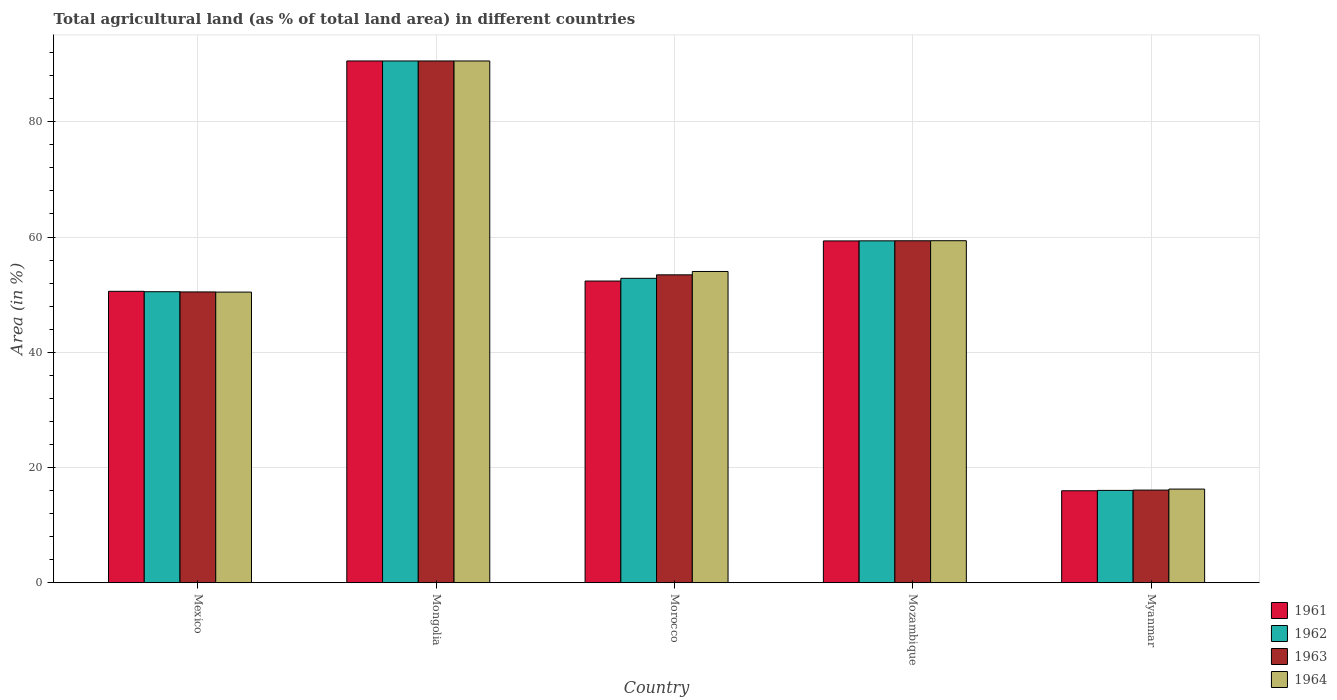How many groups of bars are there?
Give a very brief answer. 5. How many bars are there on the 5th tick from the right?
Your response must be concise. 4. What is the percentage of agricultural land in 1961 in Myanmar?
Ensure brevity in your answer.  15.96. Across all countries, what is the maximum percentage of agricultural land in 1962?
Make the answer very short. 90.56. Across all countries, what is the minimum percentage of agricultural land in 1964?
Ensure brevity in your answer.  16.25. In which country was the percentage of agricultural land in 1962 maximum?
Provide a short and direct response. Mongolia. In which country was the percentage of agricultural land in 1962 minimum?
Keep it short and to the point. Myanmar. What is the total percentage of agricultural land in 1961 in the graph?
Make the answer very short. 268.77. What is the difference between the percentage of agricultural land in 1963 in Morocco and that in Mozambique?
Offer a very short reply. -5.91. What is the difference between the percentage of agricultural land in 1961 in Mozambique and the percentage of agricultural land in 1963 in Myanmar?
Keep it short and to the point. 43.24. What is the average percentage of agricultural land in 1963 per country?
Your answer should be compact. 53.98. What is the difference between the percentage of agricultural land of/in 1963 and percentage of agricultural land of/in 1962 in Myanmar?
Provide a short and direct response. 0.06. What is the ratio of the percentage of agricultural land in 1964 in Morocco to that in Mozambique?
Your answer should be very brief. 0.91. What is the difference between the highest and the second highest percentage of agricultural land in 1961?
Offer a terse response. 31.23. What is the difference between the highest and the lowest percentage of agricultural land in 1961?
Ensure brevity in your answer.  74.6. In how many countries, is the percentage of agricultural land in 1962 greater than the average percentage of agricultural land in 1962 taken over all countries?
Make the answer very short. 2. What does the 3rd bar from the left in Mongolia represents?
Keep it short and to the point. 1963. What does the 4th bar from the right in Mexico represents?
Keep it short and to the point. 1961. How many bars are there?
Offer a very short reply. 20. How many countries are there in the graph?
Offer a very short reply. 5. What is the difference between two consecutive major ticks on the Y-axis?
Keep it short and to the point. 20. Are the values on the major ticks of Y-axis written in scientific E-notation?
Provide a short and direct response. No. Does the graph contain any zero values?
Provide a succinct answer. No. Where does the legend appear in the graph?
Keep it short and to the point. Bottom right. How many legend labels are there?
Provide a succinct answer. 4. How are the legend labels stacked?
Offer a terse response. Vertical. What is the title of the graph?
Provide a succinct answer. Total agricultural land (as % of total land area) in different countries. Does "1983" appear as one of the legend labels in the graph?
Your answer should be compact. No. What is the label or title of the X-axis?
Provide a short and direct response. Country. What is the label or title of the Y-axis?
Provide a short and direct response. Area (in %). What is the Area (in %) of 1961 in Mexico?
Provide a succinct answer. 50.58. What is the Area (in %) in 1962 in Mexico?
Make the answer very short. 50.5. What is the Area (in %) of 1963 in Mexico?
Make the answer very short. 50.47. What is the Area (in %) of 1964 in Mexico?
Offer a terse response. 50.44. What is the Area (in %) of 1961 in Mongolia?
Keep it short and to the point. 90.56. What is the Area (in %) in 1962 in Mongolia?
Offer a very short reply. 90.56. What is the Area (in %) in 1963 in Mongolia?
Offer a very short reply. 90.56. What is the Area (in %) in 1964 in Mongolia?
Give a very brief answer. 90.55. What is the Area (in %) in 1961 in Morocco?
Offer a very short reply. 52.36. What is the Area (in %) of 1962 in Morocco?
Offer a very short reply. 52.83. What is the Area (in %) of 1963 in Morocco?
Keep it short and to the point. 53.43. What is the Area (in %) of 1964 in Morocco?
Offer a terse response. 54.02. What is the Area (in %) in 1961 in Mozambique?
Offer a very short reply. 59.32. What is the Area (in %) of 1962 in Mozambique?
Keep it short and to the point. 59.34. What is the Area (in %) in 1963 in Mozambique?
Make the answer very short. 59.35. What is the Area (in %) of 1964 in Mozambique?
Provide a succinct answer. 59.36. What is the Area (in %) in 1961 in Myanmar?
Offer a very short reply. 15.96. What is the Area (in %) in 1962 in Myanmar?
Your answer should be compact. 16.02. What is the Area (in %) in 1963 in Myanmar?
Give a very brief answer. 16.08. What is the Area (in %) of 1964 in Myanmar?
Offer a terse response. 16.25. Across all countries, what is the maximum Area (in %) in 1961?
Your response must be concise. 90.56. Across all countries, what is the maximum Area (in %) in 1962?
Provide a succinct answer. 90.56. Across all countries, what is the maximum Area (in %) of 1963?
Offer a terse response. 90.56. Across all countries, what is the maximum Area (in %) of 1964?
Keep it short and to the point. 90.55. Across all countries, what is the minimum Area (in %) of 1961?
Give a very brief answer. 15.96. Across all countries, what is the minimum Area (in %) of 1962?
Keep it short and to the point. 16.02. Across all countries, what is the minimum Area (in %) in 1963?
Your response must be concise. 16.08. Across all countries, what is the minimum Area (in %) in 1964?
Your answer should be very brief. 16.25. What is the total Area (in %) of 1961 in the graph?
Make the answer very short. 268.77. What is the total Area (in %) in 1962 in the graph?
Your answer should be compact. 269.25. What is the total Area (in %) of 1963 in the graph?
Keep it short and to the point. 269.88. What is the total Area (in %) of 1964 in the graph?
Give a very brief answer. 270.62. What is the difference between the Area (in %) in 1961 in Mexico and that in Mongolia?
Your response must be concise. -39.98. What is the difference between the Area (in %) of 1962 in Mexico and that in Mongolia?
Make the answer very short. -40.05. What is the difference between the Area (in %) in 1963 in Mexico and that in Mongolia?
Make the answer very short. -40.09. What is the difference between the Area (in %) in 1964 in Mexico and that in Mongolia?
Ensure brevity in your answer.  -40.12. What is the difference between the Area (in %) in 1961 in Mexico and that in Morocco?
Offer a very short reply. -1.78. What is the difference between the Area (in %) in 1962 in Mexico and that in Morocco?
Your answer should be compact. -2.32. What is the difference between the Area (in %) of 1963 in Mexico and that in Morocco?
Keep it short and to the point. -2.97. What is the difference between the Area (in %) of 1964 in Mexico and that in Morocco?
Offer a terse response. -3.58. What is the difference between the Area (in %) in 1961 in Mexico and that in Mozambique?
Offer a very short reply. -8.75. What is the difference between the Area (in %) of 1962 in Mexico and that in Mozambique?
Provide a short and direct response. -8.83. What is the difference between the Area (in %) of 1963 in Mexico and that in Mozambique?
Make the answer very short. -8.88. What is the difference between the Area (in %) of 1964 in Mexico and that in Mozambique?
Ensure brevity in your answer.  -8.92. What is the difference between the Area (in %) of 1961 in Mexico and that in Myanmar?
Make the answer very short. 34.62. What is the difference between the Area (in %) of 1962 in Mexico and that in Myanmar?
Offer a very short reply. 34.48. What is the difference between the Area (in %) of 1963 in Mexico and that in Myanmar?
Ensure brevity in your answer.  34.39. What is the difference between the Area (in %) in 1964 in Mexico and that in Myanmar?
Make the answer very short. 34.19. What is the difference between the Area (in %) of 1961 in Mongolia and that in Morocco?
Offer a terse response. 38.2. What is the difference between the Area (in %) of 1962 in Mongolia and that in Morocco?
Keep it short and to the point. 37.73. What is the difference between the Area (in %) in 1963 in Mongolia and that in Morocco?
Offer a terse response. 37.12. What is the difference between the Area (in %) in 1964 in Mongolia and that in Morocco?
Provide a succinct answer. 36.54. What is the difference between the Area (in %) in 1961 in Mongolia and that in Mozambique?
Provide a short and direct response. 31.23. What is the difference between the Area (in %) of 1962 in Mongolia and that in Mozambique?
Provide a short and direct response. 31.22. What is the difference between the Area (in %) of 1963 in Mongolia and that in Mozambique?
Offer a very short reply. 31.21. What is the difference between the Area (in %) in 1964 in Mongolia and that in Mozambique?
Your response must be concise. 31.2. What is the difference between the Area (in %) of 1961 in Mongolia and that in Myanmar?
Offer a very short reply. 74.6. What is the difference between the Area (in %) in 1962 in Mongolia and that in Myanmar?
Provide a short and direct response. 74.53. What is the difference between the Area (in %) of 1963 in Mongolia and that in Myanmar?
Provide a succinct answer. 74.48. What is the difference between the Area (in %) of 1964 in Mongolia and that in Myanmar?
Offer a terse response. 74.3. What is the difference between the Area (in %) in 1961 in Morocco and that in Mozambique?
Ensure brevity in your answer.  -6.96. What is the difference between the Area (in %) of 1962 in Morocco and that in Mozambique?
Offer a terse response. -6.51. What is the difference between the Area (in %) of 1963 in Morocco and that in Mozambique?
Your response must be concise. -5.91. What is the difference between the Area (in %) in 1964 in Morocco and that in Mozambique?
Keep it short and to the point. -5.34. What is the difference between the Area (in %) in 1961 in Morocco and that in Myanmar?
Offer a very short reply. 36.4. What is the difference between the Area (in %) in 1962 in Morocco and that in Myanmar?
Offer a terse response. 36.81. What is the difference between the Area (in %) in 1963 in Morocco and that in Myanmar?
Offer a very short reply. 37.36. What is the difference between the Area (in %) in 1964 in Morocco and that in Myanmar?
Your response must be concise. 37.77. What is the difference between the Area (in %) of 1961 in Mozambique and that in Myanmar?
Offer a very short reply. 43.36. What is the difference between the Area (in %) of 1962 in Mozambique and that in Myanmar?
Your response must be concise. 43.31. What is the difference between the Area (in %) of 1963 in Mozambique and that in Myanmar?
Your answer should be very brief. 43.27. What is the difference between the Area (in %) in 1964 in Mozambique and that in Myanmar?
Your answer should be very brief. 43.11. What is the difference between the Area (in %) of 1961 in Mexico and the Area (in %) of 1962 in Mongolia?
Your response must be concise. -39.98. What is the difference between the Area (in %) in 1961 in Mexico and the Area (in %) in 1963 in Mongolia?
Provide a succinct answer. -39.98. What is the difference between the Area (in %) in 1961 in Mexico and the Area (in %) in 1964 in Mongolia?
Your answer should be very brief. -39.98. What is the difference between the Area (in %) of 1962 in Mexico and the Area (in %) of 1963 in Mongolia?
Ensure brevity in your answer.  -40.05. What is the difference between the Area (in %) in 1962 in Mexico and the Area (in %) in 1964 in Mongolia?
Keep it short and to the point. -40.05. What is the difference between the Area (in %) in 1963 in Mexico and the Area (in %) in 1964 in Mongolia?
Offer a terse response. -40.09. What is the difference between the Area (in %) in 1961 in Mexico and the Area (in %) in 1962 in Morocco?
Offer a terse response. -2.25. What is the difference between the Area (in %) of 1961 in Mexico and the Area (in %) of 1963 in Morocco?
Offer a very short reply. -2.86. What is the difference between the Area (in %) of 1961 in Mexico and the Area (in %) of 1964 in Morocco?
Ensure brevity in your answer.  -3.44. What is the difference between the Area (in %) of 1962 in Mexico and the Area (in %) of 1963 in Morocco?
Keep it short and to the point. -2.93. What is the difference between the Area (in %) of 1962 in Mexico and the Area (in %) of 1964 in Morocco?
Provide a succinct answer. -3.51. What is the difference between the Area (in %) in 1963 in Mexico and the Area (in %) in 1964 in Morocco?
Your answer should be compact. -3.55. What is the difference between the Area (in %) of 1961 in Mexico and the Area (in %) of 1962 in Mozambique?
Ensure brevity in your answer.  -8.76. What is the difference between the Area (in %) of 1961 in Mexico and the Area (in %) of 1963 in Mozambique?
Your response must be concise. -8.77. What is the difference between the Area (in %) in 1961 in Mexico and the Area (in %) in 1964 in Mozambique?
Offer a terse response. -8.78. What is the difference between the Area (in %) of 1962 in Mexico and the Area (in %) of 1963 in Mozambique?
Make the answer very short. -8.84. What is the difference between the Area (in %) in 1962 in Mexico and the Area (in %) in 1964 in Mozambique?
Offer a terse response. -8.85. What is the difference between the Area (in %) of 1963 in Mexico and the Area (in %) of 1964 in Mozambique?
Your answer should be very brief. -8.89. What is the difference between the Area (in %) in 1961 in Mexico and the Area (in %) in 1962 in Myanmar?
Your answer should be very brief. 34.55. What is the difference between the Area (in %) of 1961 in Mexico and the Area (in %) of 1963 in Myanmar?
Make the answer very short. 34.5. What is the difference between the Area (in %) in 1961 in Mexico and the Area (in %) in 1964 in Myanmar?
Your response must be concise. 34.33. What is the difference between the Area (in %) in 1962 in Mexico and the Area (in %) in 1963 in Myanmar?
Give a very brief answer. 34.43. What is the difference between the Area (in %) in 1962 in Mexico and the Area (in %) in 1964 in Myanmar?
Make the answer very short. 34.25. What is the difference between the Area (in %) in 1963 in Mexico and the Area (in %) in 1964 in Myanmar?
Offer a very short reply. 34.22. What is the difference between the Area (in %) of 1961 in Mongolia and the Area (in %) of 1962 in Morocco?
Your answer should be very brief. 37.73. What is the difference between the Area (in %) in 1961 in Mongolia and the Area (in %) in 1963 in Morocco?
Keep it short and to the point. 37.12. What is the difference between the Area (in %) in 1961 in Mongolia and the Area (in %) in 1964 in Morocco?
Offer a very short reply. 36.54. What is the difference between the Area (in %) in 1962 in Mongolia and the Area (in %) in 1963 in Morocco?
Offer a terse response. 37.12. What is the difference between the Area (in %) of 1962 in Mongolia and the Area (in %) of 1964 in Morocco?
Provide a short and direct response. 36.54. What is the difference between the Area (in %) in 1963 in Mongolia and the Area (in %) in 1964 in Morocco?
Your answer should be compact. 36.54. What is the difference between the Area (in %) of 1961 in Mongolia and the Area (in %) of 1962 in Mozambique?
Give a very brief answer. 31.22. What is the difference between the Area (in %) in 1961 in Mongolia and the Area (in %) in 1963 in Mozambique?
Offer a very short reply. 31.21. What is the difference between the Area (in %) in 1961 in Mongolia and the Area (in %) in 1964 in Mozambique?
Offer a terse response. 31.2. What is the difference between the Area (in %) of 1962 in Mongolia and the Area (in %) of 1963 in Mozambique?
Give a very brief answer. 31.21. What is the difference between the Area (in %) of 1962 in Mongolia and the Area (in %) of 1964 in Mozambique?
Make the answer very short. 31.2. What is the difference between the Area (in %) in 1963 in Mongolia and the Area (in %) in 1964 in Mozambique?
Your answer should be very brief. 31.2. What is the difference between the Area (in %) in 1961 in Mongolia and the Area (in %) in 1962 in Myanmar?
Your answer should be very brief. 74.53. What is the difference between the Area (in %) of 1961 in Mongolia and the Area (in %) of 1963 in Myanmar?
Offer a terse response. 74.48. What is the difference between the Area (in %) in 1961 in Mongolia and the Area (in %) in 1964 in Myanmar?
Keep it short and to the point. 74.31. What is the difference between the Area (in %) in 1962 in Mongolia and the Area (in %) in 1963 in Myanmar?
Offer a very short reply. 74.48. What is the difference between the Area (in %) in 1962 in Mongolia and the Area (in %) in 1964 in Myanmar?
Make the answer very short. 74.31. What is the difference between the Area (in %) of 1963 in Mongolia and the Area (in %) of 1964 in Myanmar?
Offer a terse response. 74.31. What is the difference between the Area (in %) in 1961 in Morocco and the Area (in %) in 1962 in Mozambique?
Your response must be concise. -6.98. What is the difference between the Area (in %) of 1961 in Morocco and the Area (in %) of 1963 in Mozambique?
Your answer should be compact. -6.99. What is the difference between the Area (in %) of 1961 in Morocco and the Area (in %) of 1964 in Mozambique?
Provide a succinct answer. -7. What is the difference between the Area (in %) in 1962 in Morocco and the Area (in %) in 1963 in Mozambique?
Make the answer very short. -6.52. What is the difference between the Area (in %) in 1962 in Morocco and the Area (in %) in 1964 in Mozambique?
Keep it short and to the point. -6.53. What is the difference between the Area (in %) of 1963 in Morocco and the Area (in %) of 1964 in Mozambique?
Provide a short and direct response. -5.92. What is the difference between the Area (in %) of 1961 in Morocco and the Area (in %) of 1962 in Myanmar?
Offer a very short reply. 36.34. What is the difference between the Area (in %) of 1961 in Morocco and the Area (in %) of 1963 in Myanmar?
Offer a terse response. 36.28. What is the difference between the Area (in %) of 1961 in Morocco and the Area (in %) of 1964 in Myanmar?
Provide a short and direct response. 36.11. What is the difference between the Area (in %) in 1962 in Morocco and the Area (in %) in 1963 in Myanmar?
Your answer should be very brief. 36.75. What is the difference between the Area (in %) of 1962 in Morocco and the Area (in %) of 1964 in Myanmar?
Give a very brief answer. 36.58. What is the difference between the Area (in %) in 1963 in Morocco and the Area (in %) in 1964 in Myanmar?
Give a very brief answer. 37.18. What is the difference between the Area (in %) in 1961 in Mozambique and the Area (in %) in 1962 in Myanmar?
Provide a short and direct response. 43.3. What is the difference between the Area (in %) in 1961 in Mozambique and the Area (in %) in 1963 in Myanmar?
Your response must be concise. 43.24. What is the difference between the Area (in %) in 1961 in Mozambique and the Area (in %) in 1964 in Myanmar?
Offer a very short reply. 43.07. What is the difference between the Area (in %) in 1962 in Mozambique and the Area (in %) in 1963 in Myanmar?
Keep it short and to the point. 43.26. What is the difference between the Area (in %) of 1962 in Mozambique and the Area (in %) of 1964 in Myanmar?
Give a very brief answer. 43.09. What is the difference between the Area (in %) in 1963 in Mozambique and the Area (in %) in 1964 in Myanmar?
Offer a terse response. 43.1. What is the average Area (in %) of 1961 per country?
Your response must be concise. 53.75. What is the average Area (in %) of 1962 per country?
Offer a terse response. 53.85. What is the average Area (in %) of 1963 per country?
Ensure brevity in your answer.  53.98. What is the average Area (in %) in 1964 per country?
Make the answer very short. 54.12. What is the difference between the Area (in %) in 1961 and Area (in %) in 1962 in Mexico?
Provide a short and direct response. 0.07. What is the difference between the Area (in %) in 1961 and Area (in %) in 1963 in Mexico?
Ensure brevity in your answer.  0.11. What is the difference between the Area (in %) of 1961 and Area (in %) of 1964 in Mexico?
Make the answer very short. 0.14. What is the difference between the Area (in %) of 1962 and Area (in %) of 1963 in Mexico?
Provide a succinct answer. 0.04. What is the difference between the Area (in %) of 1962 and Area (in %) of 1964 in Mexico?
Your answer should be compact. 0.07. What is the difference between the Area (in %) of 1963 and Area (in %) of 1964 in Mexico?
Ensure brevity in your answer.  0.03. What is the difference between the Area (in %) in 1961 and Area (in %) in 1964 in Mongolia?
Provide a short and direct response. 0. What is the difference between the Area (in %) of 1962 and Area (in %) of 1963 in Mongolia?
Ensure brevity in your answer.  0. What is the difference between the Area (in %) of 1962 and Area (in %) of 1964 in Mongolia?
Ensure brevity in your answer.  0. What is the difference between the Area (in %) of 1963 and Area (in %) of 1964 in Mongolia?
Make the answer very short. 0. What is the difference between the Area (in %) in 1961 and Area (in %) in 1962 in Morocco?
Keep it short and to the point. -0.47. What is the difference between the Area (in %) of 1961 and Area (in %) of 1963 in Morocco?
Ensure brevity in your answer.  -1.08. What is the difference between the Area (in %) of 1961 and Area (in %) of 1964 in Morocco?
Provide a succinct answer. -1.66. What is the difference between the Area (in %) of 1962 and Area (in %) of 1963 in Morocco?
Provide a short and direct response. -0.6. What is the difference between the Area (in %) of 1962 and Area (in %) of 1964 in Morocco?
Keep it short and to the point. -1.19. What is the difference between the Area (in %) of 1963 and Area (in %) of 1964 in Morocco?
Offer a very short reply. -0.58. What is the difference between the Area (in %) of 1961 and Area (in %) of 1962 in Mozambique?
Offer a terse response. -0.01. What is the difference between the Area (in %) of 1961 and Area (in %) of 1963 in Mozambique?
Give a very brief answer. -0.03. What is the difference between the Area (in %) of 1961 and Area (in %) of 1964 in Mozambique?
Your answer should be very brief. -0.04. What is the difference between the Area (in %) in 1962 and Area (in %) in 1963 in Mozambique?
Provide a succinct answer. -0.01. What is the difference between the Area (in %) of 1962 and Area (in %) of 1964 in Mozambique?
Your answer should be very brief. -0.02. What is the difference between the Area (in %) in 1963 and Area (in %) in 1964 in Mozambique?
Make the answer very short. -0.01. What is the difference between the Area (in %) of 1961 and Area (in %) of 1962 in Myanmar?
Keep it short and to the point. -0.06. What is the difference between the Area (in %) in 1961 and Area (in %) in 1963 in Myanmar?
Offer a terse response. -0.12. What is the difference between the Area (in %) in 1961 and Area (in %) in 1964 in Myanmar?
Your answer should be compact. -0.29. What is the difference between the Area (in %) in 1962 and Area (in %) in 1963 in Myanmar?
Provide a succinct answer. -0.06. What is the difference between the Area (in %) of 1962 and Area (in %) of 1964 in Myanmar?
Your answer should be very brief. -0.23. What is the difference between the Area (in %) in 1963 and Area (in %) in 1964 in Myanmar?
Keep it short and to the point. -0.17. What is the ratio of the Area (in %) in 1961 in Mexico to that in Mongolia?
Keep it short and to the point. 0.56. What is the ratio of the Area (in %) of 1962 in Mexico to that in Mongolia?
Make the answer very short. 0.56. What is the ratio of the Area (in %) of 1963 in Mexico to that in Mongolia?
Keep it short and to the point. 0.56. What is the ratio of the Area (in %) in 1964 in Mexico to that in Mongolia?
Keep it short and to the point. 0.56. What is the ratio of the Area (in %) of 1961 in Mexico to that in Morocco?
Ensure brevity in your answer.  0.97. What is the ratio of the Area (in %) in 1962 in Mexico to that in Morocco?
Your answer should be compact. 0.96. What is the ratio of the Area (in %) of 1963 in Mexico to that in Morocco?
Offer a terse response. 0.94. What is the ratio of the Area (in %) in 1964 in Mexico to that in Morocco?
Give a very brief answer. 0.93. What is the ratio of the Area (in %) of 1961 in Mexico to that in Mozambique?
Offer a very short reply. 0.85. What is the ratio of the Area (in %) of 1962 in Mexico to that in Mozambique?
Offer a very short reply. 0.85. What is the ratio of the Area (in %) of 1963 in Mexico to that in Mozambique?
Give a very brief answer. 0.85. What is the ratio of the Area (in %) in 1964 in Mexico to that in Mozambique?
Provide a short and direct response. 0.85. What is the ratio of the Area (in %) of 1961 in Mexico to that in Myanmar?
Provide a short and direct response. 3.17. What is the ratio of the Area (in %) in 1962 in Mexico to that in Myanmar?
Provide a succinct answer. 3.15. What is the ratio of the Area (in %) of 1963 in Mexico to that in Myanmar?
Your answer should be compact. 3.14. What is the ratio of the Area (in %) of 1964 in Mexico to that in Myanmar?
Offer a very short reply. 3.1. What is the ratio of the Area (in %) in 1961 in Mongolia to that in Morocco?
Give a very brief answer. 1.73. What is the ratio of the Area (in %) of 1962 in Mongolia to that in Morocco?
Provide a short and direct response. 1.71. What is the ratio of the Area (in %) of 1963 in Mongolia to that in Morocco?
Provide a short and direct response. 1.69. What is the ratio of the Area (in %) in 1964 in Mongolia to that in Morocco?
Offer a very short reply. 1.68. What is the ratio of the Area (in %) in 1961 in Mongolia to that in Mozambique?
Your response must be concise. 1.53. What is the ratio of the Area (in %) of 1962 in Mongolia to that in Mozambique?
Your answer should be very brief. 1.53. What is the ratio of the Area (in %) in 1963 in Mongolia to that in Mozambique?
Offer a very short reply. 1.53. What is the ratio of the Area (in %) in 1964 in Mongolia to that in Mozambique?
Offer a very short reply. 1.53. What is the ratio of the Area (in %) in 1961 in Mongolia to that in Myanmar?
Give a very brief answer. 5.67. What is the ratio of the Area (in %) in 1962 in Mongolia to that in Myanmar?
Your answer should be compact. 5.65. What is the ratio of the Area (in %) of 1963 in Mongolia to that in Myanmar?
Your answer should be compact. 5.63. What is the ratio of the Area (in %) in 1964 in Mongolia to that in Myanmar?
Provide a short and direct response. 5.57. What is the ratio of the Area (in %) in 1961 in Morocco to that in Mozambique?
Ensure brevity in your answer.  0.88. What is the ratio of the Area (in %) of 1962 in Morocco to that in Mozambique?
Provide a short and direct response. 0.89. What is the ratio of the Area (in %) in 1963 in Morocco to that in Mozambique?
Your response must be concise. 0.9. What is the ratio of the Area (in %) of 1964 in Morocco to that in Mozambique?
Your answer should be compact. 0.91. What is the ratio of the Area (in %) in 1961 in Morocco to that in Myanmar?
Your answer should be very brief. 3.28. What is the ratio of the Area (in %) of 1962 in Morocco to that in Myanmar?
Make the answer very short. 3.3. What is the ratio of the Area (in %) of 1963 in Morocco to that in Myanmar?
Ensure brevity in your answer.  3.32. What is the ratio of the Area (in %) in 1964 in Morocco to that in Myanmar?
Give a very brief answer. 3.32. What is the ratio of the Area (in %) in 1961 in Mozambique to that in Myanmar?
Offer a terse response. 3.72. What is the ratio of the Area (in %) of 1962 in Mozambique to that in Myanmar?
Your answer should be very brief. 3.7. What is the ratio of the Area (in %) of 1963 in Mozambique to that in Myanmar?
Your answer should be very brief. 3.69. What is the ratio of the Area (in %) of 1964 in Mozambique to that in Myanmar?
Your answer should be very brief. 3.65. What is the difference between the highest and the second highest Area (in %) in 1961?
Provide a succinct answer. 31.23. What is the difference between the highest and the second highest Area (in %) of 1962?
Offer a very short reply. 31.22. What is the difference between the highest and the second highest Area (in %) of 1963?
Provide a short and direct response. 31.21. What is the difference between the highest and the second highest Area (in %) of 1964?
Ensure brevity in your answer.  31.2. What is the difference between the highest and the lowest Area (in %) of 1961?
Give a very brief answer. 74.6. What is the difference between the highest and the lowest Area (in %) of 1962?
Provide a succinct answer. 74.53. What is the difference between the highest and the lowest Area (in %) of 1963?
Your answer should be compact. 74.48. What is the difference between the highest and the lowest Area (in %) of 1964?
Ensure brevity in your answer.  74.3. 